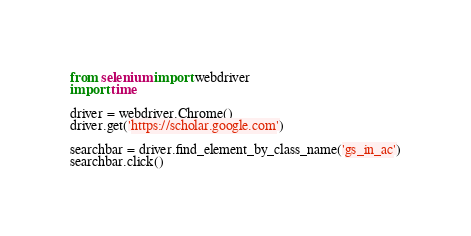<code> <loc_0><loc_0><loc_500><loc_500><_Python_>from selenium import webdriver
import time

driver = webdriver.Chrome()
driver.get('https://scholar.google.com')

searchbar = driver.find_element_by_class_name('gs_in_ac')
searchbar.click()</code> 